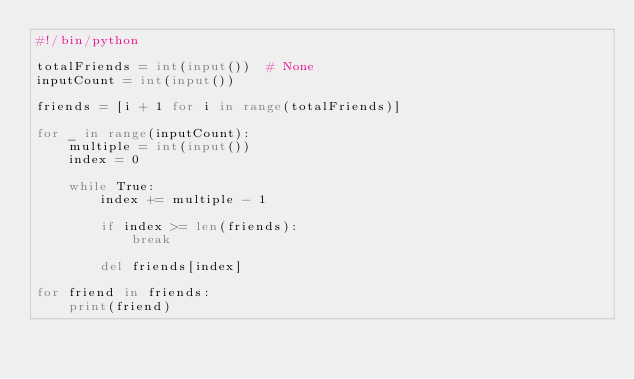Convert code to text. <code><loc_0><loc_0><loc_500><loc_500><_Python_>#!/bin/python

totalFriends = int(input())  # None
inputCount = int(input())

friends = [i + 1 for i in range(totalFriends)]

for _ in range(inputCount):
    multiple = int(input())
    index = 0

    while True:
        index += multiple - 1

        if index >= len(friends):
            break

        del friends[index]

for friend in friends:
    print(friend)
</code> 